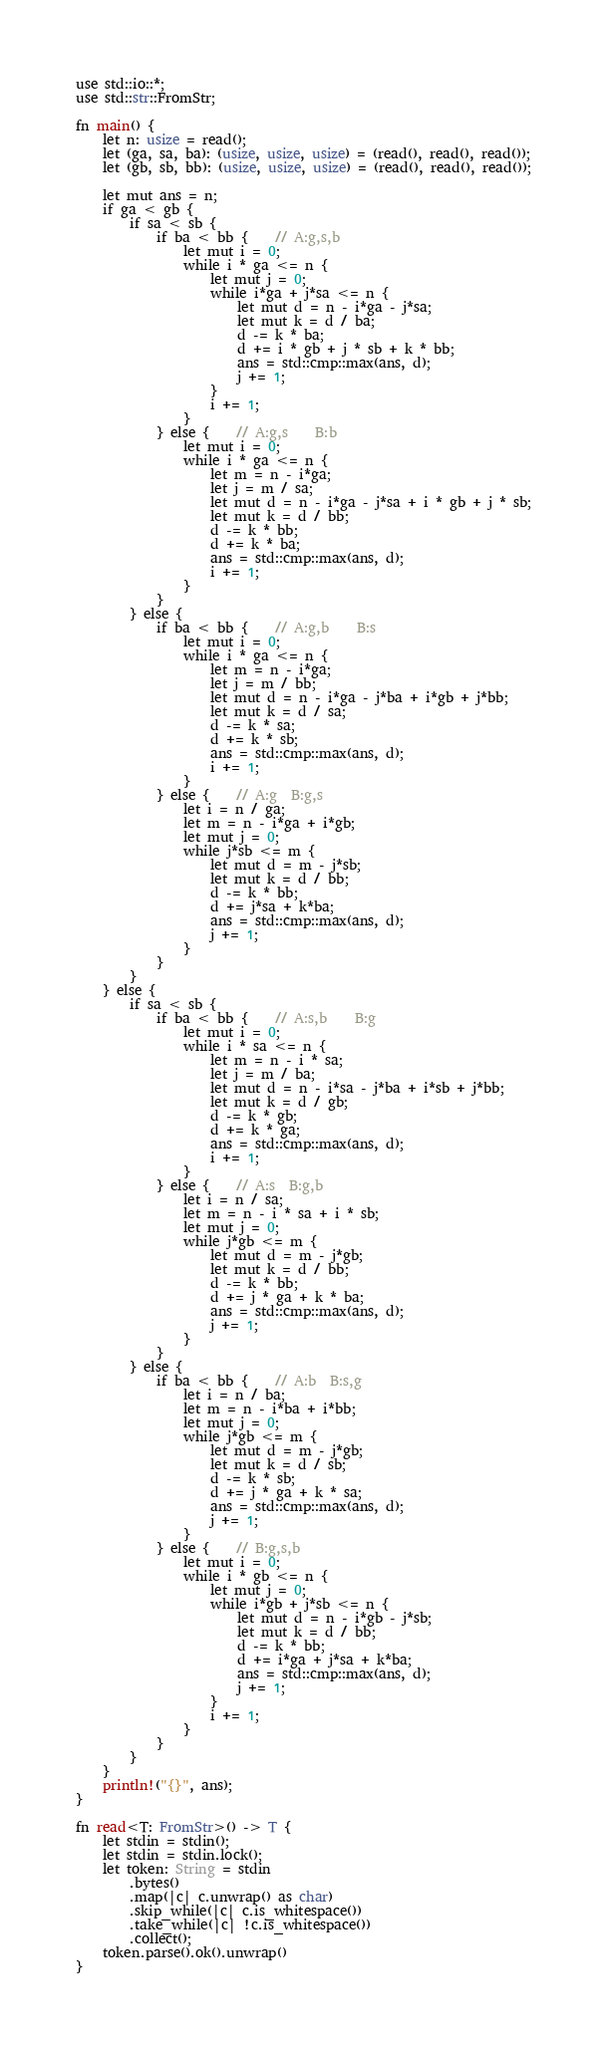Convert code to text. <code><loc_0><loc_0><loc_500><loc_500><_Rust_>use std::io::*;
use std::str::FromStr;

fn main() {
    let n: usize = read();
    let (ga, sa, ba): (usize, usize, usize) = (read(), read(), read());
    let (gb, sb, bb): (usize, usize, usize) = (read(), read(), read());

    let mut ans = n;
    if ga < gb {
        if sa < sb {
            if ba < bb {    // A:g,s,b
                let mut i = 0;
                while i * ga <= n {
                    let mut j = 0;
                    while i*ga + j*sa <= n {
                        let mut d = n - i*ga - j*sa;
                        let mut k = d / ba;
                        d -= k * ba;
                        d += i * gb + j * sb + k * bb;
                        ans = std::cmp::max(ans, d);
                        j += 1;
                    }
                    i += 1;
                }
            } else {    // A:g,s    B:b
                let mut i = 0;
                while i * ga <= n {
                    let m = n - i*ga;
                    let j = m / sa;
                    let mut d = n - i*ga - j*sa + i * gb + j * sb;
                    let mut k = d / bb;
                    d -= k * bb;
                    d += k * ba;
                    ans = std::cmp::max(ans, d);
                    i += 1;
                }
            }
        } else {
            if ba < bb {    // A:g,b    B:s
                let mut i = 0;
                while i * ga <= n {
                    let m = n - i*ga;
                    let j = m / bb;
                    let mut d = n - i*ga - j*ba + i*gb + j*bb;
                    let mut k = d / sa;
                    d -= k * sa;
                    d += k * sb;
                    ans = std::cmp::max(ans, d);
                    i += 1;
                }
            } else {    // A:g  B:g,s
                let i = n / ga;
                let m = n - i*ga + i*gb;
                let mut j = 0;
                while j*sb <= m {
                    let mut d = m - j*sb;
                    let mut k = d / bb;
                    d -= k * bb;
                    d += j*sa + k*ba;
                    ans = std::cmp::max(ans, d);
                    j += 1;
                }
            }
        }
    } else {
        if sa < sb {
            if ba < bb {    // A:s,b    B:g
                let mut i = 0;
                while i * sa <= n {
                    let m = n - i * sa;
                    let j = m / ba;
                    let mut d = n - i*sa - j*ba + i*sb + j*bb;
                    let mut k = d / gb;
                    d -= k * gb;
                    d += k * ga;
                    ans = std::cmp::max(ans, d);
                    i += 1;
                }
            } else {    // A:s  B:g,b
                let i = n / sa;
                let m = n - i * sa + i * sb;
                let mut j = 0;
                while j*gb <= m {
                    let mut d = m - j*gb;
                    let mut k = d / bb;
                    d -= k * bb;
                    d += j * ga + k * ba;
                    ans = std::cmp::max(ans, d);
                    j += 1;
                }
            }
        } else {
            if ba < bb {    // A:b  B:s,g
                let i = n / ba;
                let m = n - i*ba + i*bb;
                let mut j = 0;
                while j*gb <= m {
                    let mut d = m - j*gb;
                    let mut k = d / sb;
                    d -= k * sb;
                    d += j * ga + k * sa;
                    ans = std::cmp::max(ans, d);
                    j += 1;
                }
            } else {    // B:g,s,b
                let mut i = 0;
                while i * gb <= n {
                    let mut j = 0;
                    while i*gb + j*sb <= n {
                        let mut d = n - i*gb - j*sb;
                        let mut k = d / bb;
                        d -= k * bb;
                        d += i*ga + j*sa + k*ba;
                        ans = std::cmp::max(ans, d);
                        j += 1;
                    }
                    i += 1;
                }
            }
        }
    }
    println!("{}", ans);
}

fn read<T: FromStr>() -> T {
    let stdin = stdin();
    let stdin = stdin.lock();
    let token: String = stdin
        .bytes()
        .map(|c| c.unwrap() as char)
        .skip_while(|c| c.is_whitespace())
        .take_while(|c| !c.is_whitespace())
        .collect();
    token.parse().ok().unwrap()
}
</code> 